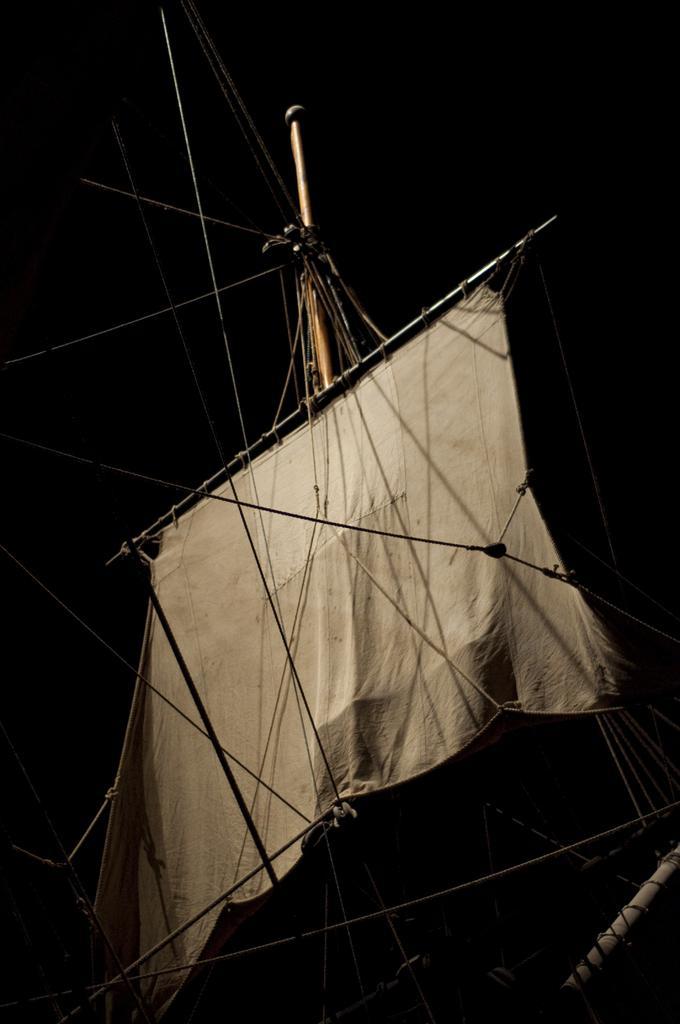Can you describe this image briefly? In this image I can see cloth, rod and ropes. In the background of the image it is dark. 